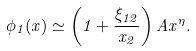<formula> <loc_0><loc_0><loc_500><loc_500>\phi _ { 1 } ( x ) \simeq \left ( 1 + \frac { \xi _ { 1 2 } } { x _ { 2 } } \right ) A x ^ { \eta } .</formula> 